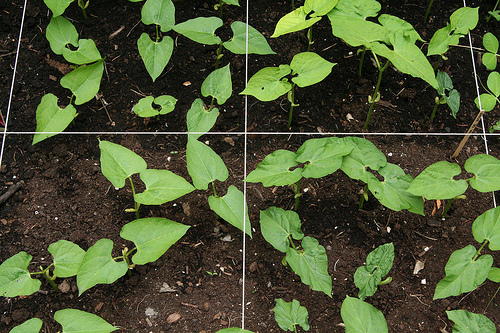<image>
Is there a plants on the sand? Yes. Looking at the image, I can see the plants is positioned on top of the sand, with the sand providing support. Is the tiny plant in the soil? Yes. The tiny plant is contained within or inside the soil, showing a containment relationship. 